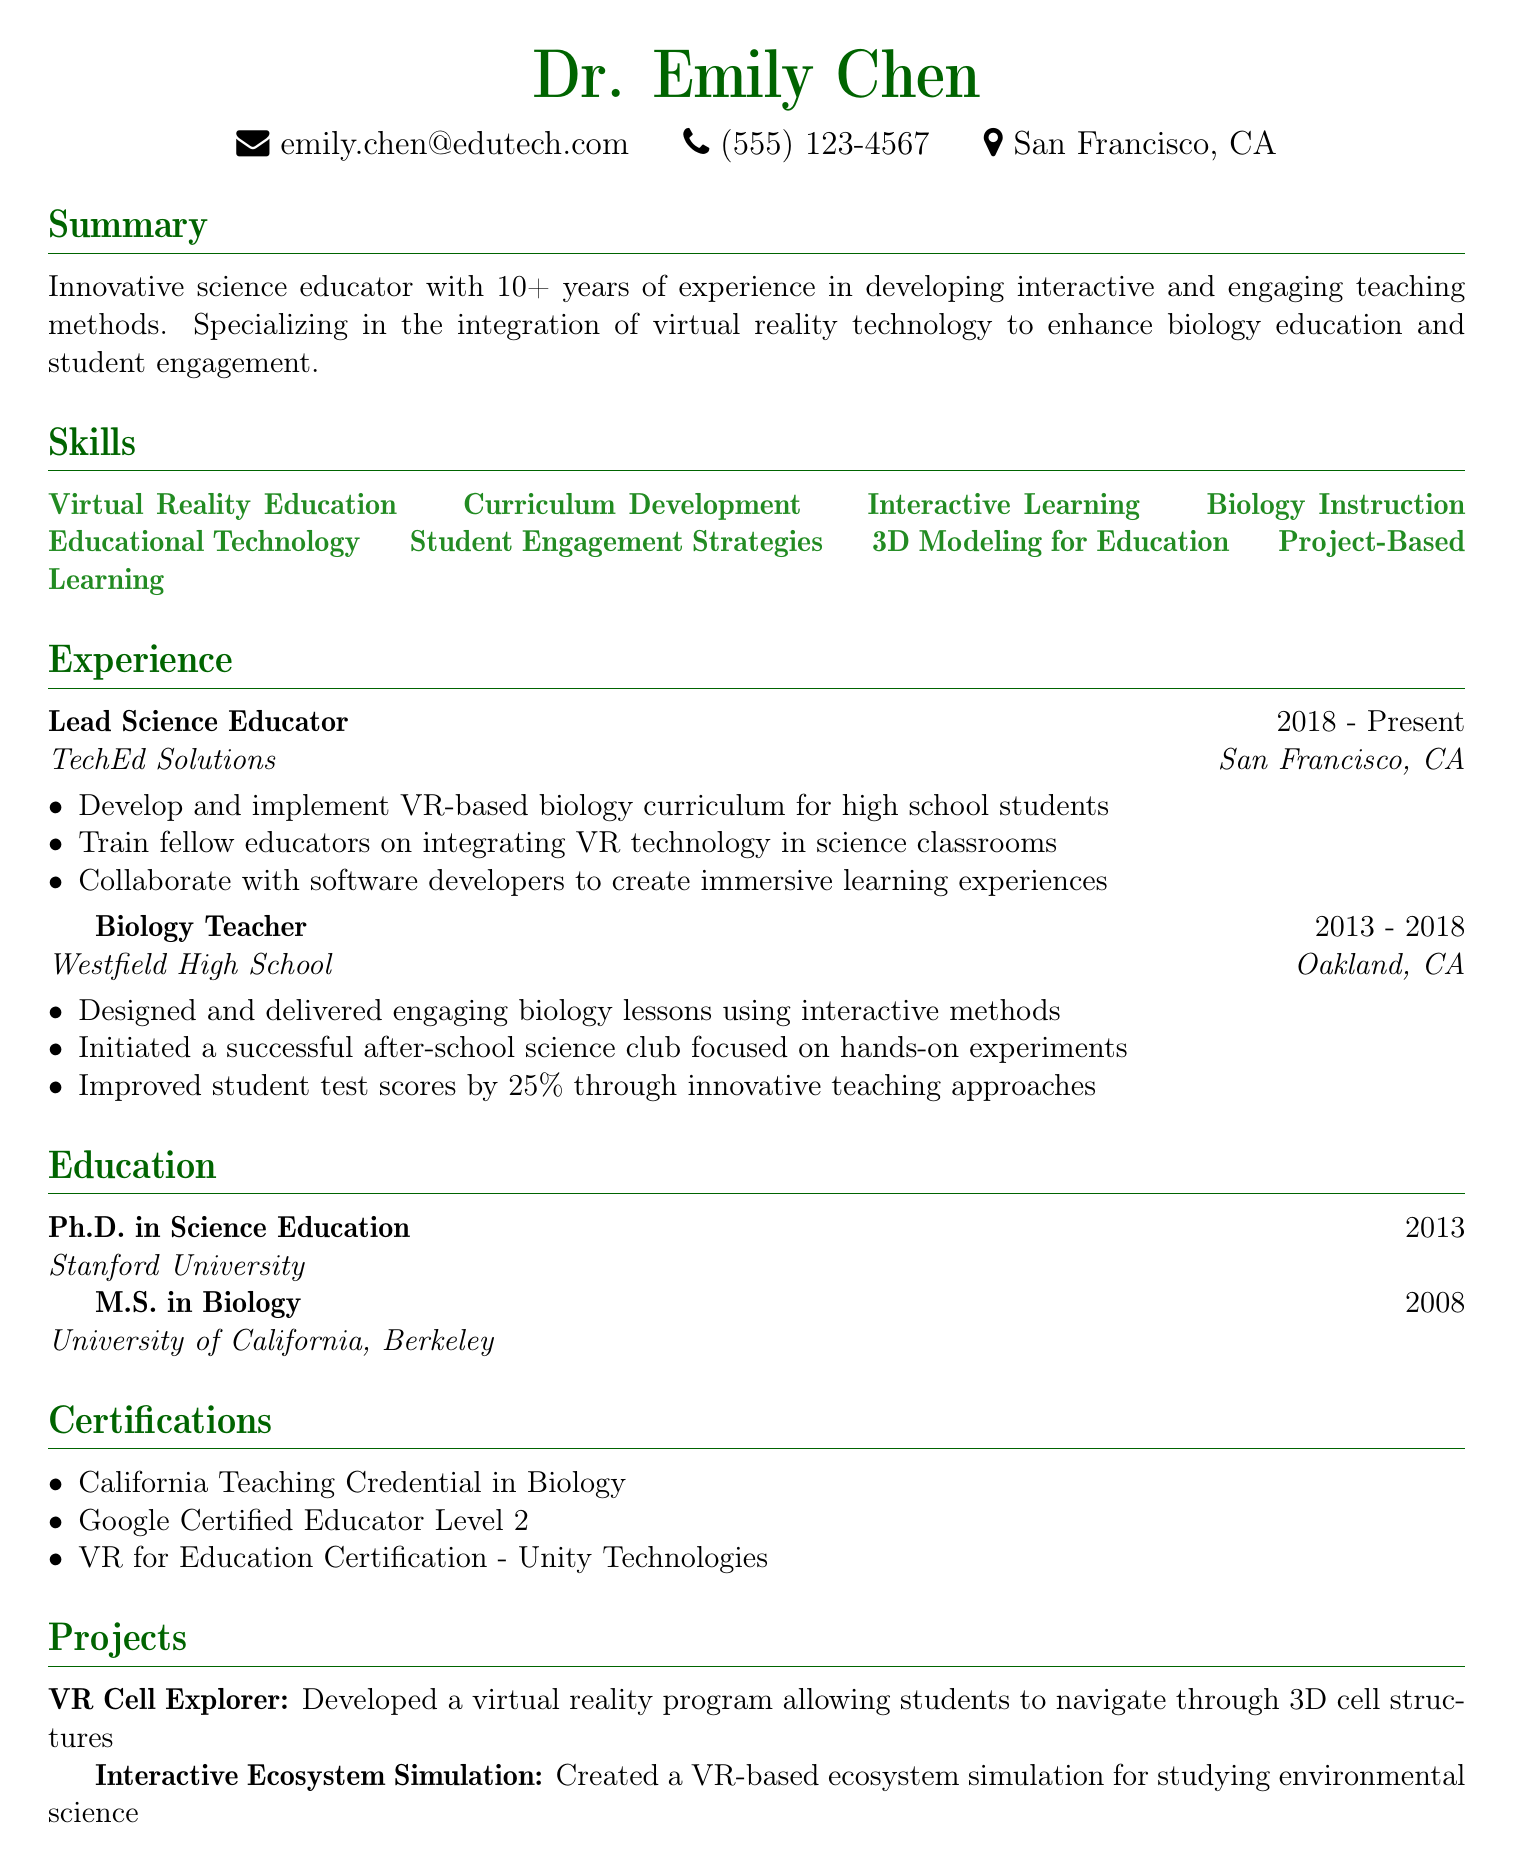what is the name of the educator? The document starts with the personal information section that includes the name of the educator, which is Dr. Emily Chen.
Answer: Dr. Emily Chen how many years of experience does she have? In the summary, it states that she has over 10 years of experience in education.
Answer: 10+ what is one of her specializations? The summary highlights her specialization in integrating virtual reality technology to enhance biology education.
Answer: Virtual reality technology what company did she work for from 2013 to 2018? The experience section lists her role and company during that period as a Biology Teacher at Westfield High School.
Answer: Westfield High School what percentage did she improve student test scores by? The responsibility under her role as a Biology Teacher mentions that she improved student test scores by 25%.
Answer: 25% name one project she developed. The projects section lists two, including the VR Cell Explorer, which allows navigation through 3D cell structures.
Answer: VR Cell Explorer which degree did she earn in 2013? The education section indicates that she earned a Ph.D. in Science Education in 2013.
Answer: Ph.D. in Science Education how many certifications does Dr. Emily Chen have listed? The certifications section lists three certifications in total.
Answer: 3 where is Dr. Emily Chen located? The personal info section reveals her location, which is San Francisco, CA.
Answer: San Francisco, CA 